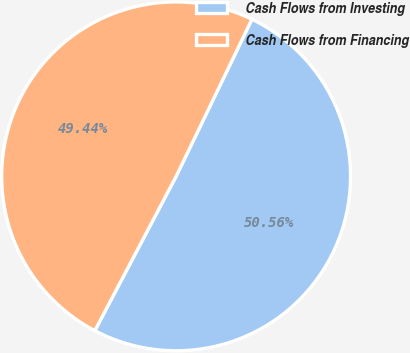Convert chart to OTSL. <chart><loc_0><loc_0><loc_500><loc_500><pie_chart><fcel>Cash Flows from Investing<fcel>Cash Flows from Financing<nl><fcel>50.56%<fcel>49.44%<nl></chart> 